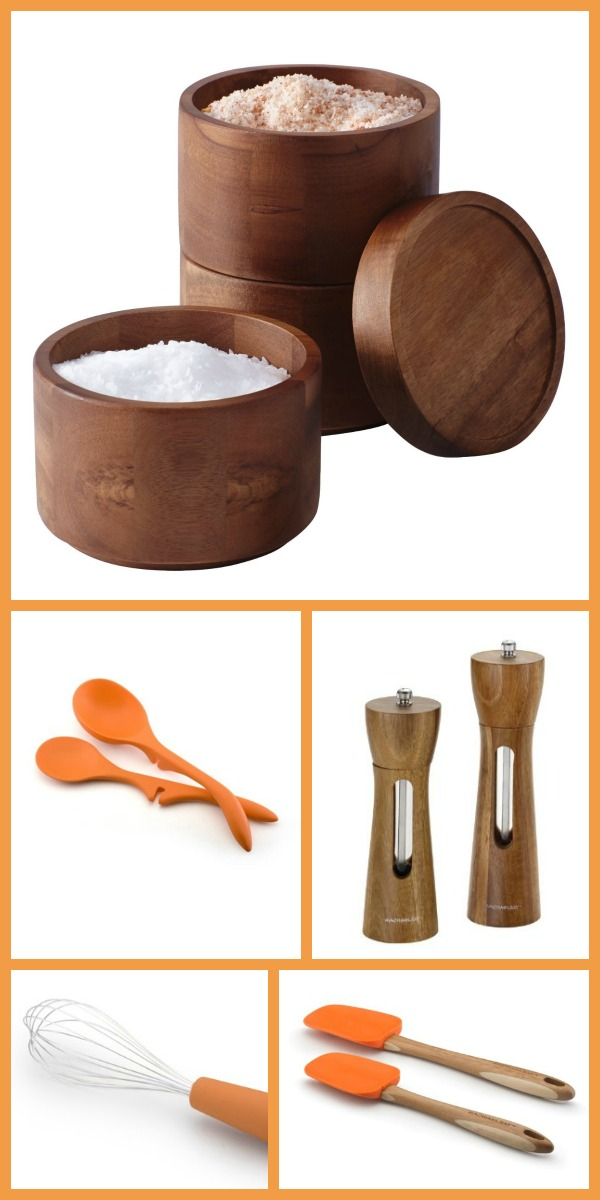In a futuristic world, how might these kitchen tools evolve to enhance our cooking experience? In a futuristic world, these kitchen tools could evolve with smart technology embedded within them. The wooden containers might have built-in sensors that can detect the freshness of the food stored inside and send notifications to your smart device when supplies are running low. The silicone utensils could be equipped with temperature regulators to ensure food is cooked at the optimal temperature, preventing overheating or burning. The salt and pepper grinders might come with flavor detectors that automatically adjust seasoning based on the dish being prepared, enhancing culinary precision and creativity. Such advancements would marry tradition with innovation, revolutionizing the cooking experience. 